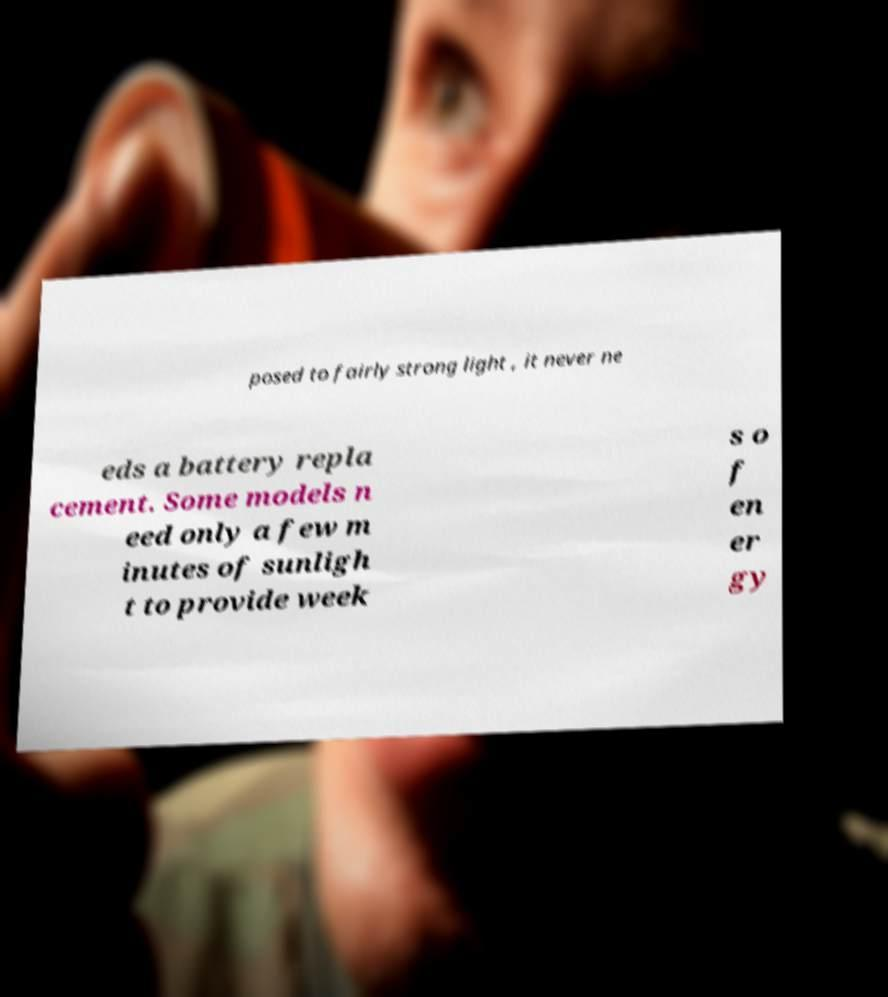Please read and relay the text visible in this image. What does it say? posed to fairly strong light , it never ne eds a battery repla cement. Some models n eed only a few m inutes of sunligh t to provide week s o f en er gy 